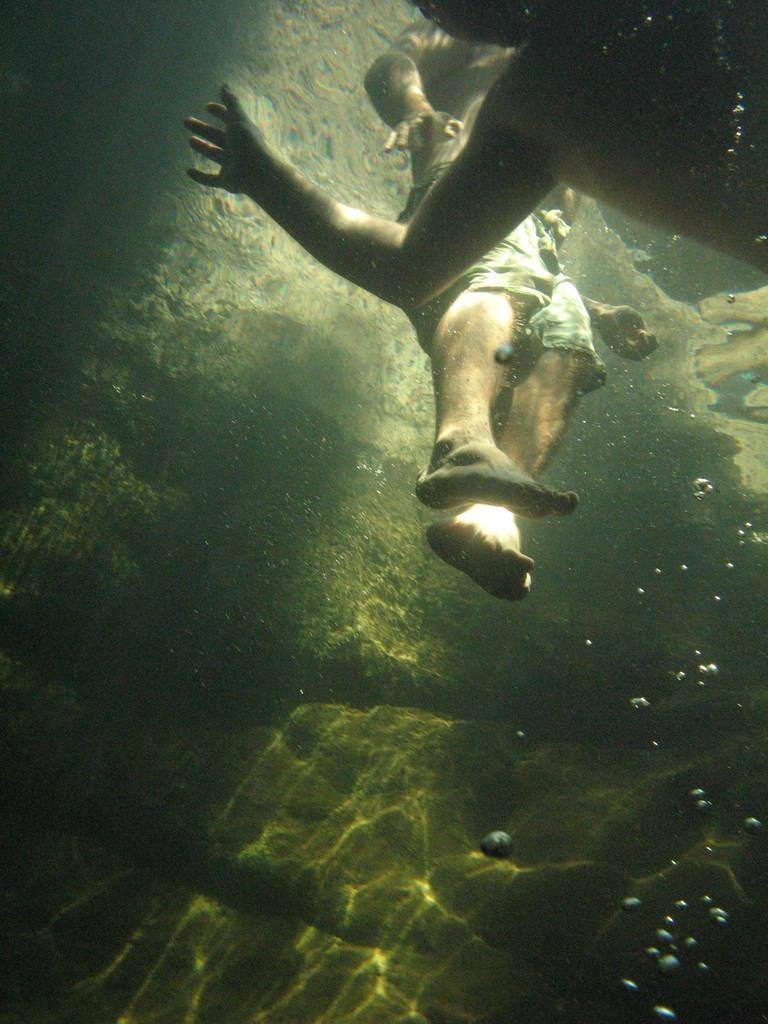How many people are in the image? There are two people in the image. What are the two people doing in the image? The two people are in the water. What type of sweater is the person wearing in the image? There is no sweater mentioned or visible in the image, as the two people are in the water. 